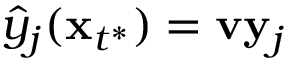Convert formula to latex. <formula><loc_0><loc_0><loc_500><loc_500>\hat { y } _ { j } ( \mathbf x _ { t ^ { * } } ) = v \mathbf y _ { j }</formula> 